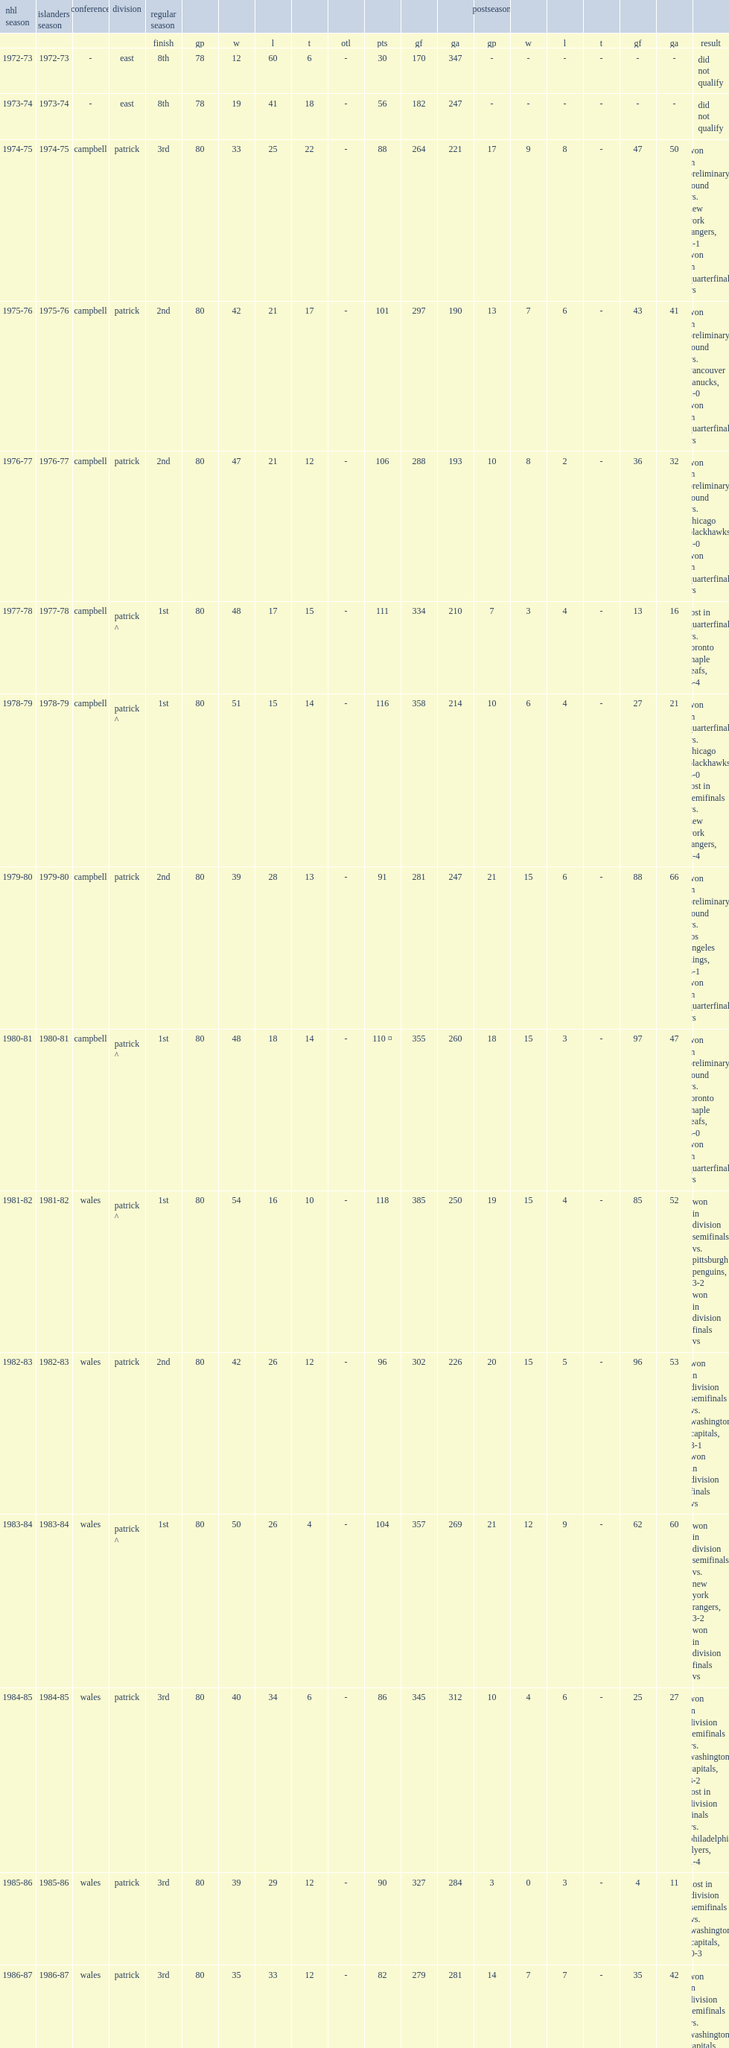List the first season in the franchise's history of islanders season. 1972-73. 